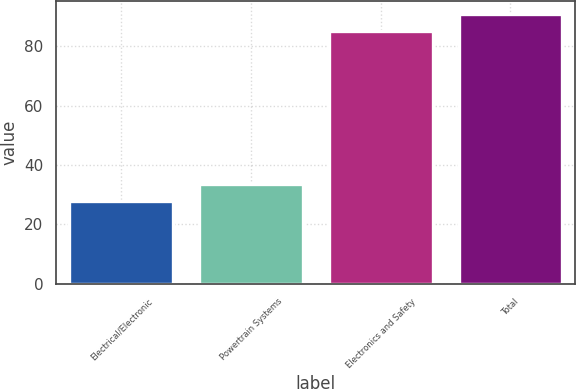Convert chart. <chart><loc_0><loc_0><loc_500><loc_500><bar_chart><fcel>Electrical/Electronic<fcel>Powertrain Systems<fcel>Electronics and Safety<fcel>Total<nl><fcel>28<fcel>33.7<fcel>85<fcel>90.7<nl></chart> 